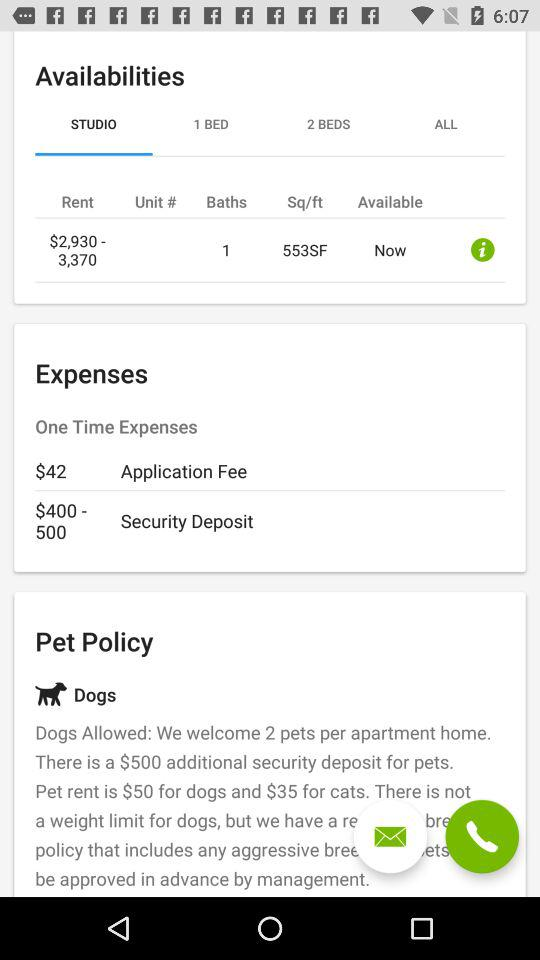Which tab is selected? The selected tab is "STUDIO". 